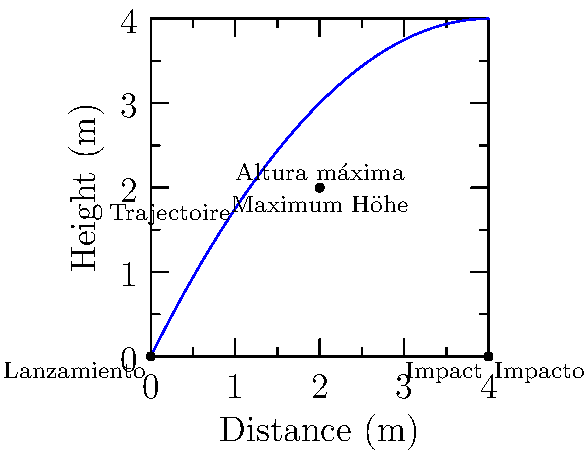In a multilingual physics demonstration, a projectile is launched from the origin. The trajectory is shown in the graph, with key points labeled in different languages. If the projectile reaches its maximum height at $t = 1$ second, what is the initial velocity vector $\vec{v_0}$ in terms of $\langle v_x, v_y \rangle$? Let's approach this step-by-step:

1) From the graph, we can see that the projectile follows a parabolic path, typical of projectile motion under constant gravity.

2) The maximum height occurs at $t = 1$ second, which is half the total time of flight. This means the total time of flight is 2 seconds.

3) The horizontal distance traveled is 4 meters in 2 seconds. So, the horizontal velocity $v_x$ is constant and equal to:

   $v_x = \frac{4 \text{ m}}{2 \text{ s}} = 2 \text{ m/s}$

4) At the highest point, the vertical velocity $v_y$ is zero. Since this occurs at $t = 1$ s, we can use the equation:

   $v_y = v_{0y} - gt$

   Where $v_{0y}$ is the initial vertical velocity, $g$ is the acceleration due to gravity (9.8 m/s²), and $t = 1$ s.

   $0 = v_{0y} - 9.8 \cdot 1$
   $v_{0y} = 9.8 \text{ m/s}$

5) Therefore, the initial velocity vector is:

   $\vec{v_0} = \langle 2, 9.8 \rangle \text{ m/s}$

This solution demonstrates the universality of physics principles across languages, supporting the idea of linguistic diversity in scientific education.
Answer: $\vec{v_0} = \langle 2, 9.8 \rangle \text{ m/s}$ 